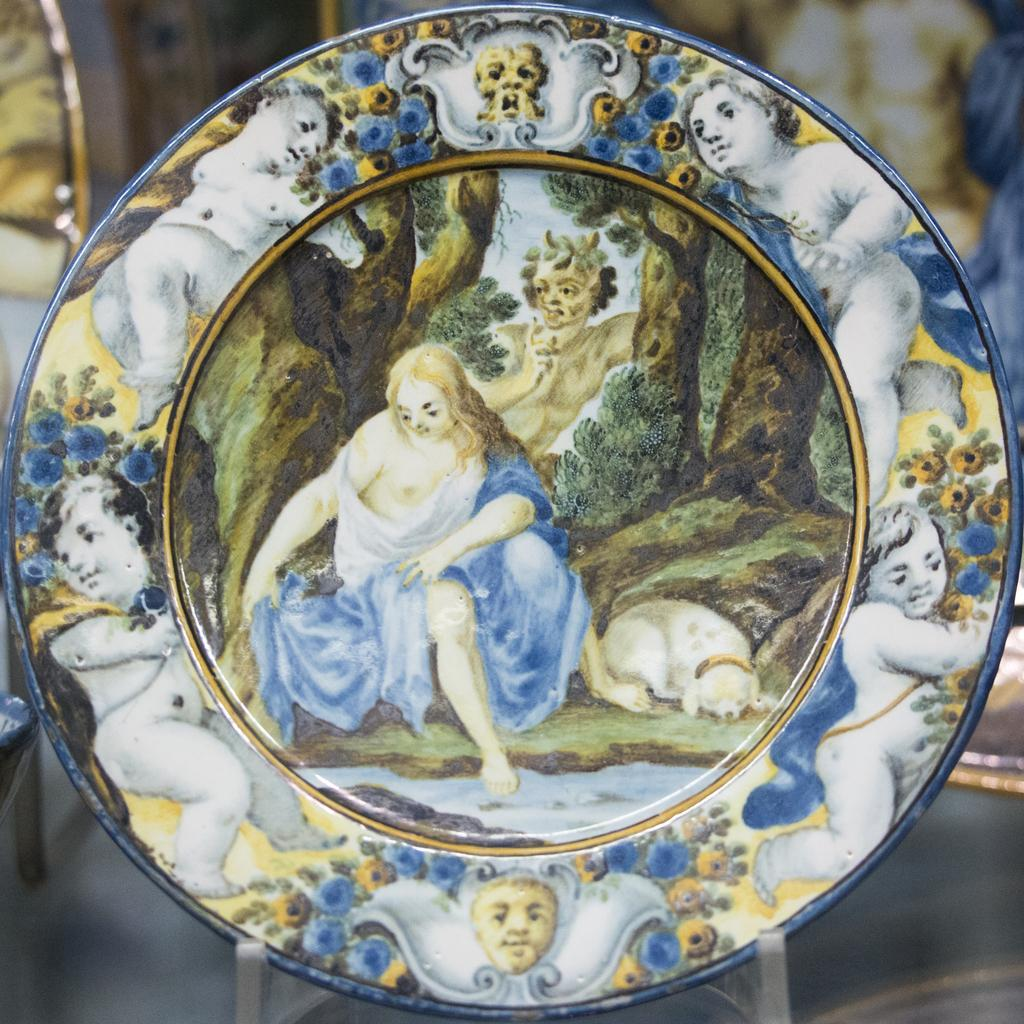What is the main subject of the image? There is a decorated plate in the image. Can you describe the appearance of the plate? Unfortunately, the facts provided do not give any details about the appearance of the plate. What can be seen behind the plate in the image? There are blurred objects behind the plate in the image. What type of coil is wrapped around the plate in the image? There is no coil present in the image. The main subject is the decorated plate, and there are blurred objects behind it. 